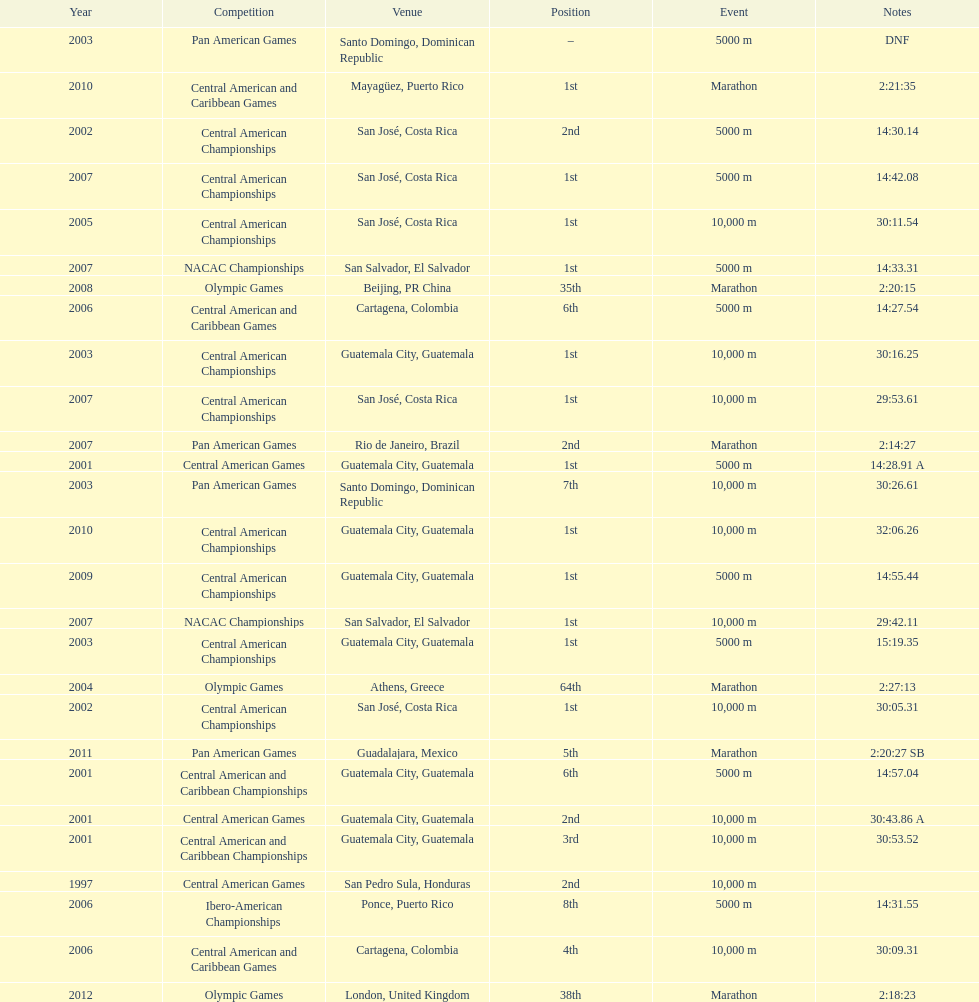What was the last competition in which a position of "2nd" was achieved? Pan American Games. 